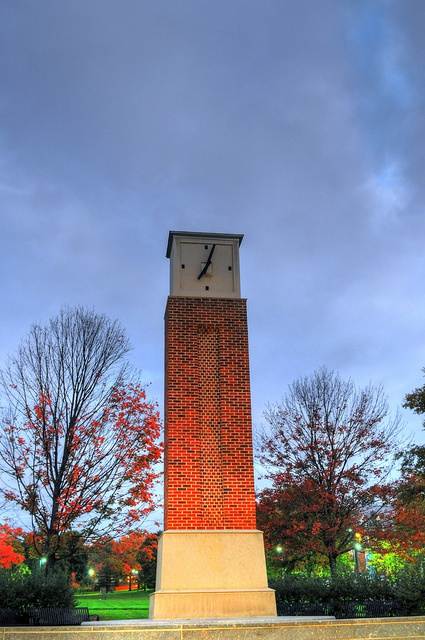Describe the objects in this image and their specific colors. I can see clock in gray and black tones and bench in gray, black, darkgreen, and teal tones in this image. 